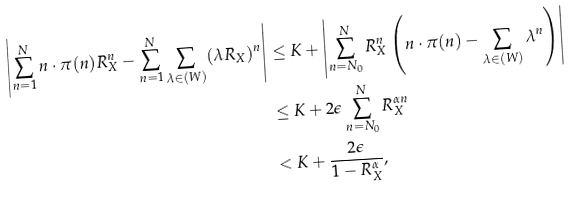<formula> <loc_0><loc_0><loc_500><loc_500>\left | \sum _ { n = 1 } ^ { N } n \cdot \pi ( n ) R _ { X } ^ { n } - \sum _ { n = 1 } ^ { N } \sum _ { \lambda \in ( W ) } ( \lambda R _ { X } ) ^ { n } \right | & \leq K + \left | \sum _ { n = N _ { 0 } } ^ { N } R _ { X } ^ { n } \left ( n \cdot \pi ( n ) - \sum _ { \lambda \in ( W ) } \lambda ^ { n } \right ) \right | \\ & \leq K + 2 \epsilon \sum _ { n = N _ { 0 } } ^ { N } R _ { X } ^ { \alpha n } \\ & < K + \frac { 2 \epsilon } { 1 - R _ { X } ^ { \alpha } } ,</formula> 